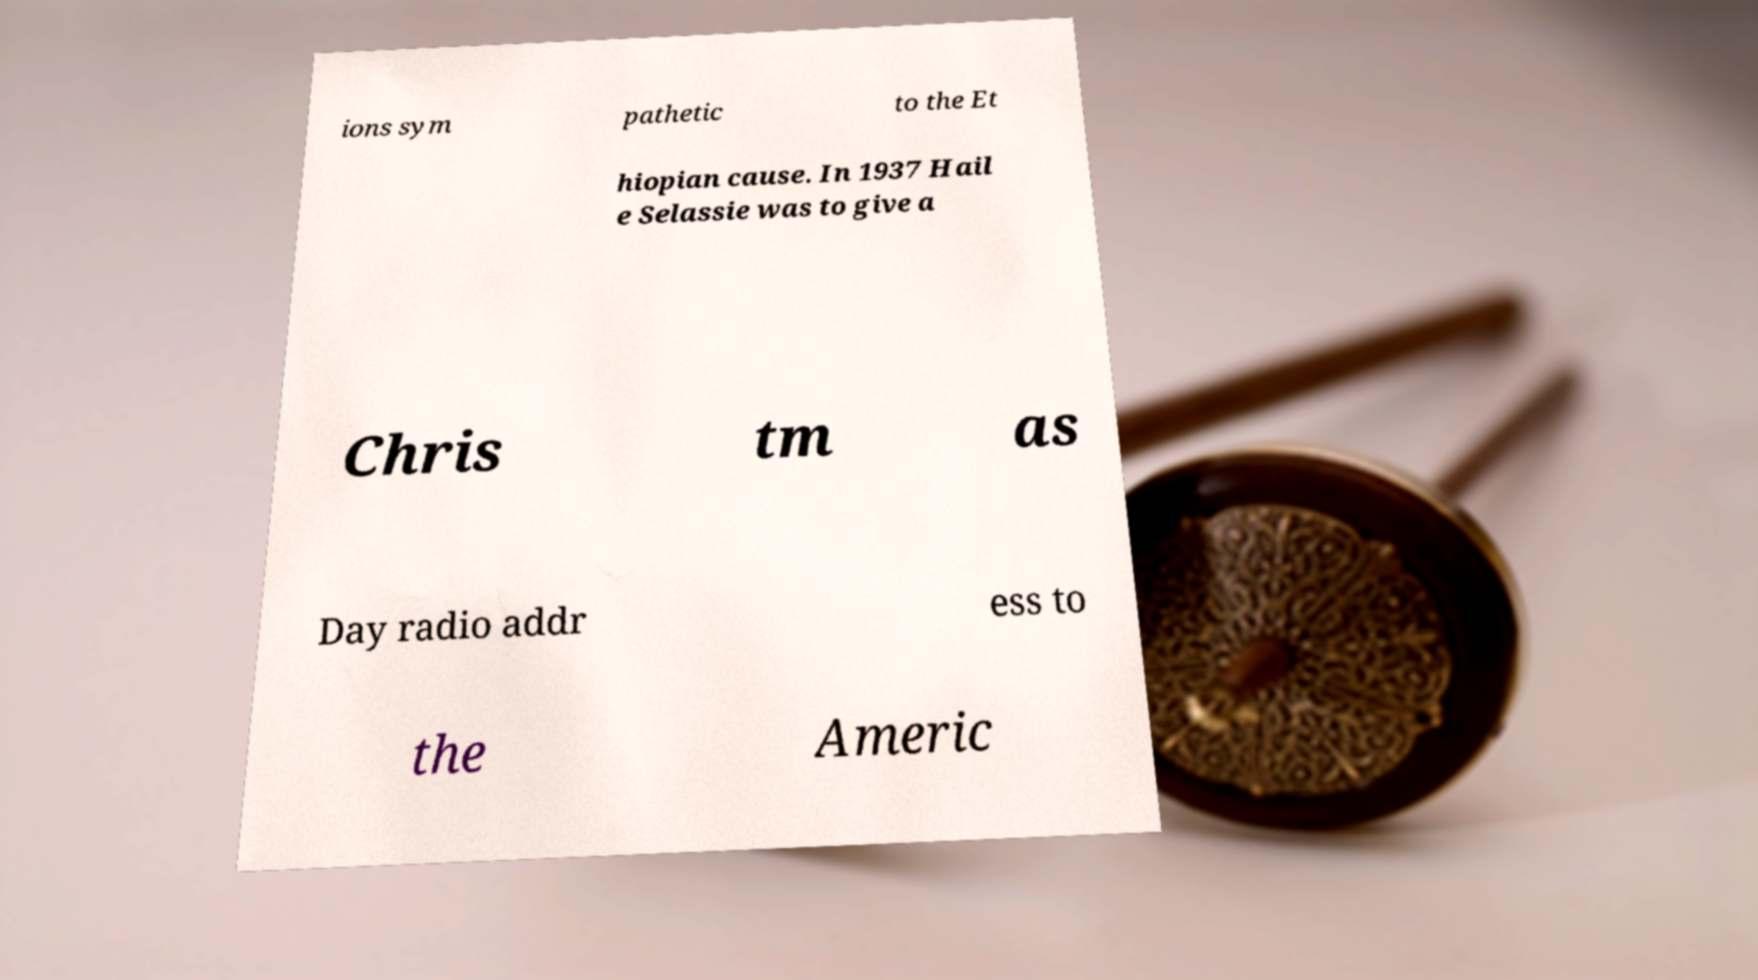Please read and relay the text visible in this image. What does it say? ions sym pathetic to the Et hiopian cause. In 1937 Hail e Selassie was to give a Chris tm as Day radio addr ess to the Americ 